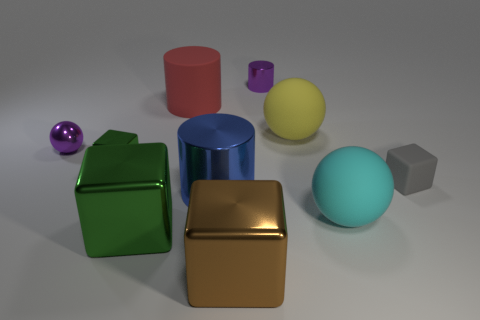What number of objects are cylinders that are to the left of the large blue cylinder or tiny purple objects?
Your answer should be compact. 3. The small matte thing has what color?
Offer a terse response. Gray. There is a cylinder behind the large red object; what material is it?
Keep it short and to the point. Metal. Does the blue object have the same shape as the purple thing behind the yellow ball?
Provide a short and direct response. Yes. Is the number of shiny spheres greater than the number of blue rubber blocks?
Provide a short and direct response. Yes. Is there anything else that is the same color as the tiny metallic sphere?
Provide a succinct answer. Yes. There is a large green object that is the same material as the brown block; what shape is it?
Give a very brief answer. Cube. The big cube that is on the left side of the matte thing left of the yellow sphere is made of what material?
Offer a terse response. Metal. Does the purple thing that is on the left side of the purple cylinder have the same shape as the blue shiny object?
Ensure brevity in your answer.  No. Are there more small metallic objects that are in front of the gray rubber block than small green metal cubes?
Your response must be concise. No. 